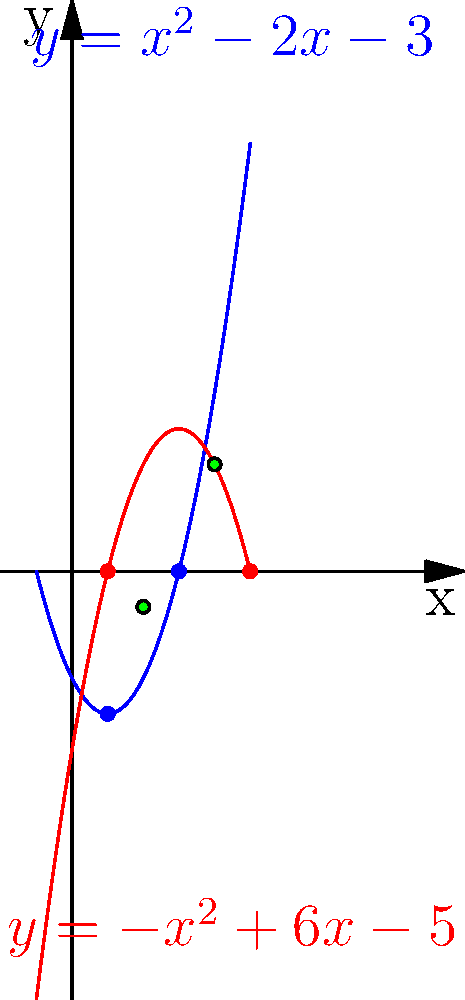Your mentor has challenged you to analyze the intersection points of two parabolas. The blue parabola is represented by the equation $y = x^2 - 2x - 3$, and the red parabola is represented by the equation $y = -x^2 + 6x - 5$. What are the x-coordinates of the intersection points of these two parabolas? Let's approach this step-by-step:

1) To find the intersection points, we need to set the equations equal to each other:
   $x^2 - 2x - 3 = -x^2 + 6x - 5$

2) Rearrange the equation so that all terms are on one side:
   $2x^2 - 8x + 2 = 0$

3) Divide all terms by 2 to simplify:
   $x^2 - 4x + 1 = 0$

4) This is a quadratic equation. We can solve it using the quadratic formula:
   $x = \frac{-b \pm \sqrt{b^2 - 4ac}}{2a}$

   Where $a = 1$, $b = -4$, and $c = 1$

5) Plugging these values into the quadratic formula:
   $x = \frac{4 \pm \sqrt{16 - 4}}{2} = \frac{4 \pm \sqrt{12}}{2} = \frac{4 \pm 2\sqrt{3}}{2}$

6) Simplify:
   $x = 2 \pm \sqrt{3}$

7) Therefore, the two x-coordinates are:
   $x_1 = 2 + \sqrt{3}$ and $x_2 = 2 - \sqrt{3}$

8) We can approximate these values:
   $x_1 \approx 3.73$ and $x_2 \approx 0.27$

The graph confirms that there are indeed two intersection points, with x-coordinates between 0 and 1, and between 3 and 4.
Answer: $x = 2 \pm \sqrt{3}$ 